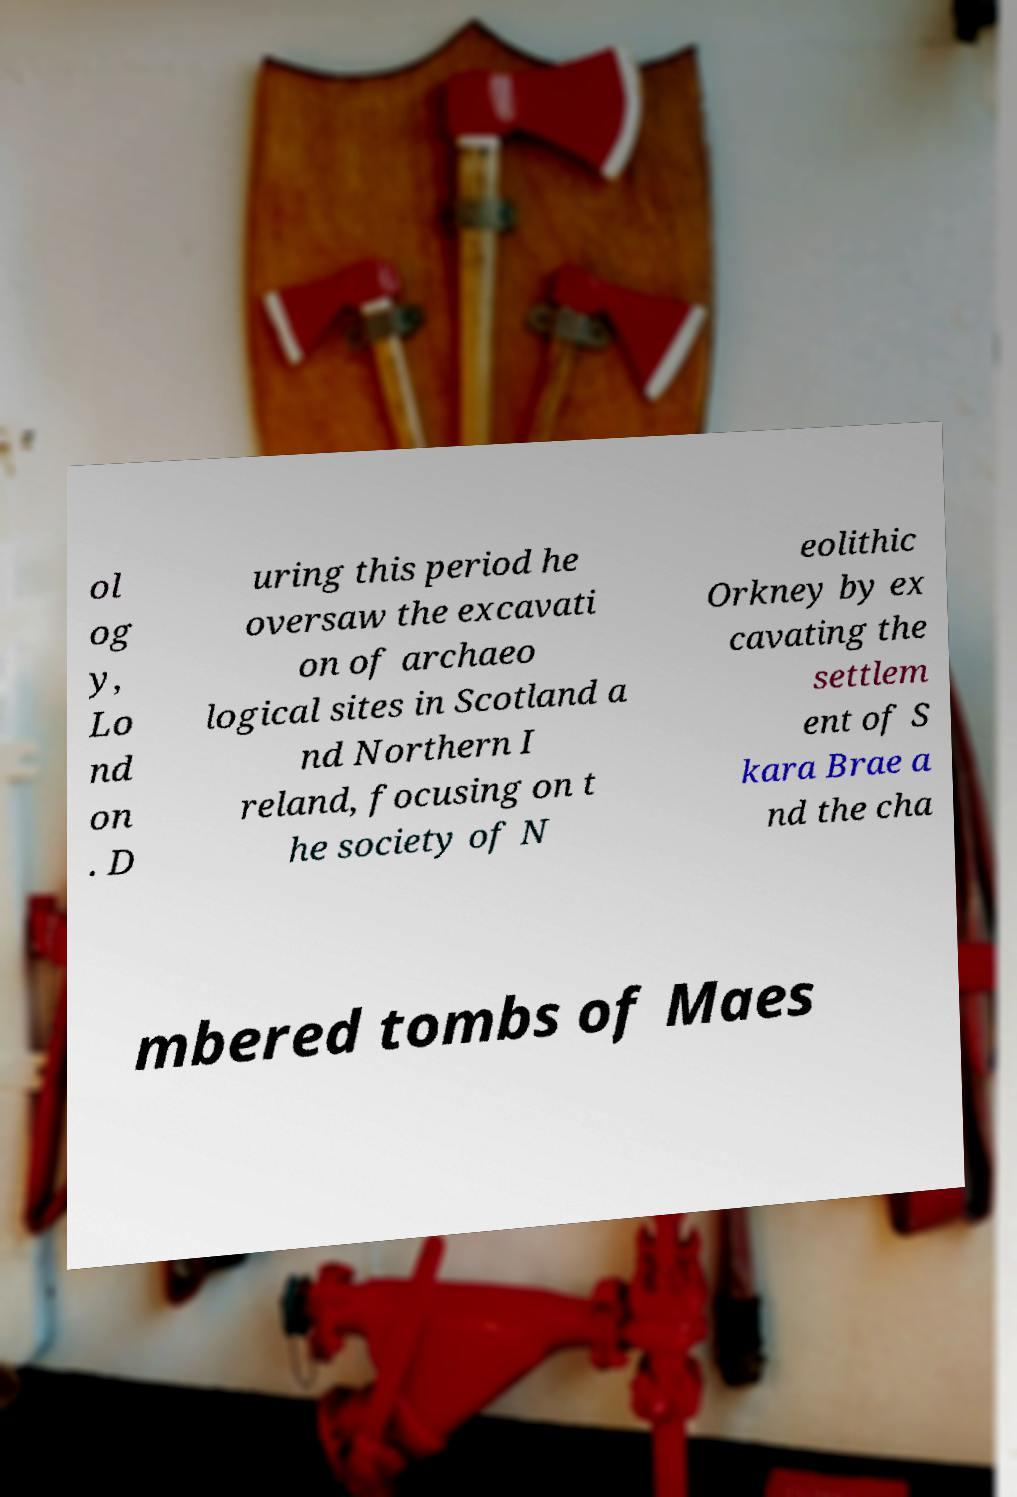What messages or text are displayed in this image? I need them in a readable, typed format. ol og y, Lo nd on . D uring this period he oversaw the excavati on of archaeo logical sites in Scotland a nd Northern I reland, focusing on t he society of N eolithic Orkney by ex cavating the settlem ent of S kara Brae a nd the cha mbered tombs of Maes 